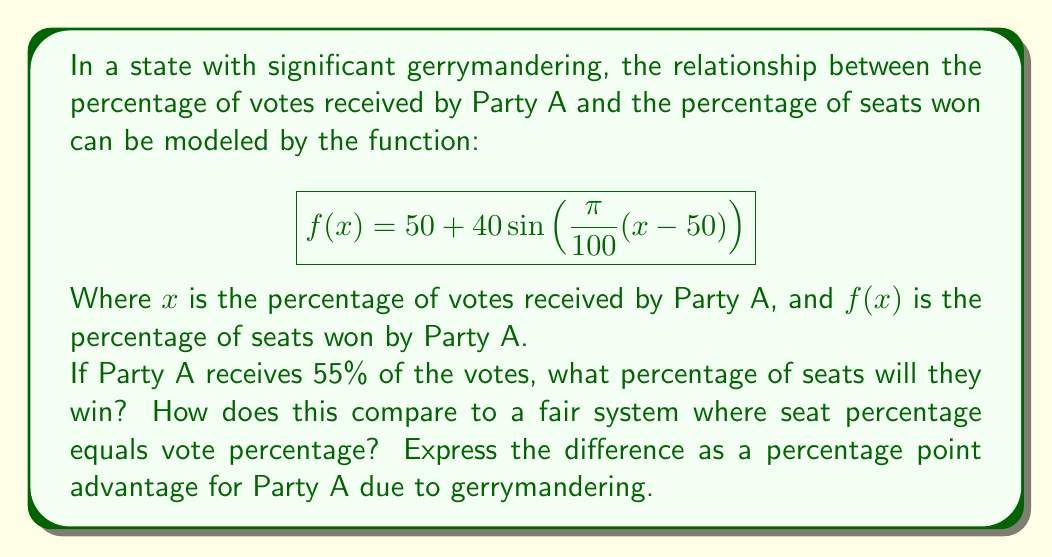Solve this math problem. To solve this problem, we need to follow these steps:

1) First, let's calculate the percentage of seats won by Party A when they receive 55% of the votes:

   $$f(55) = 50 + 40\sin(\frac{\pi}{100}(55-50))$$
   
   $$= 50 + 40\sin(\frac{5\pi}{100})$$
   
   $$\approx 50 + 40(0.1564)$$
   
   $$\approx 50 + 6.256$$
   
   $$\approx 56.256\%$$

2) In a fair system, 55% of votes would result in 55% of seats. 

3) To find the advantage due to gerrymandering, we subtract:

   $$56.256\% - 55\% = 1.256\%$$

This means Party A gains about 1.256 percentage points more seats than they would in a fair system.

This example illustrates how gerrymandering can distort representation, giving a party more seats than their vote share would suggest in a fair system. It's a clear demonstration of how mathematical modeling can reveal the impacts of political manipulation on democratic processes.
Answer: Party A will win approximately 56.256% of the seats. Compared to a fair system, they gain an advantage of about 1.256 percentage points due to gerrymandering. 